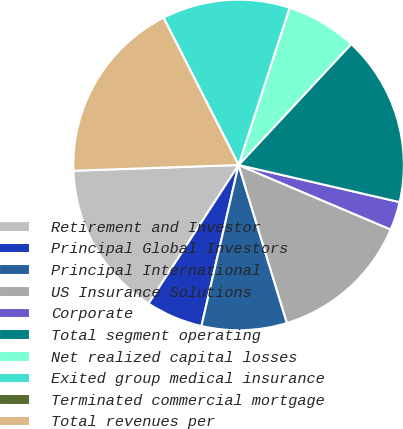Convert chart. <chart><loc_0><loc_0><loc_500><loc_500><pie_chart><fcel>Retirement and Investor<fcel>Principal Global Investors<fcel>Principal International<fcel>US Insurance Solutions<fcel>Corporate<fcel>Total segment operating<fcel>Net realized capital losses<fcel>Exited group medical insurance<fcel>Terminated commercial mortgage<fcel>Total revenues per<nl><fcel>15.28%<fcel>5.56%<fcel>8.33%<fcel>13.89%<fcel>2.78%<fcel>16.67%<fcel>6.94%<fcel>12.5%<fcel>0.0%<fcel>18.05%<nl></chart> 